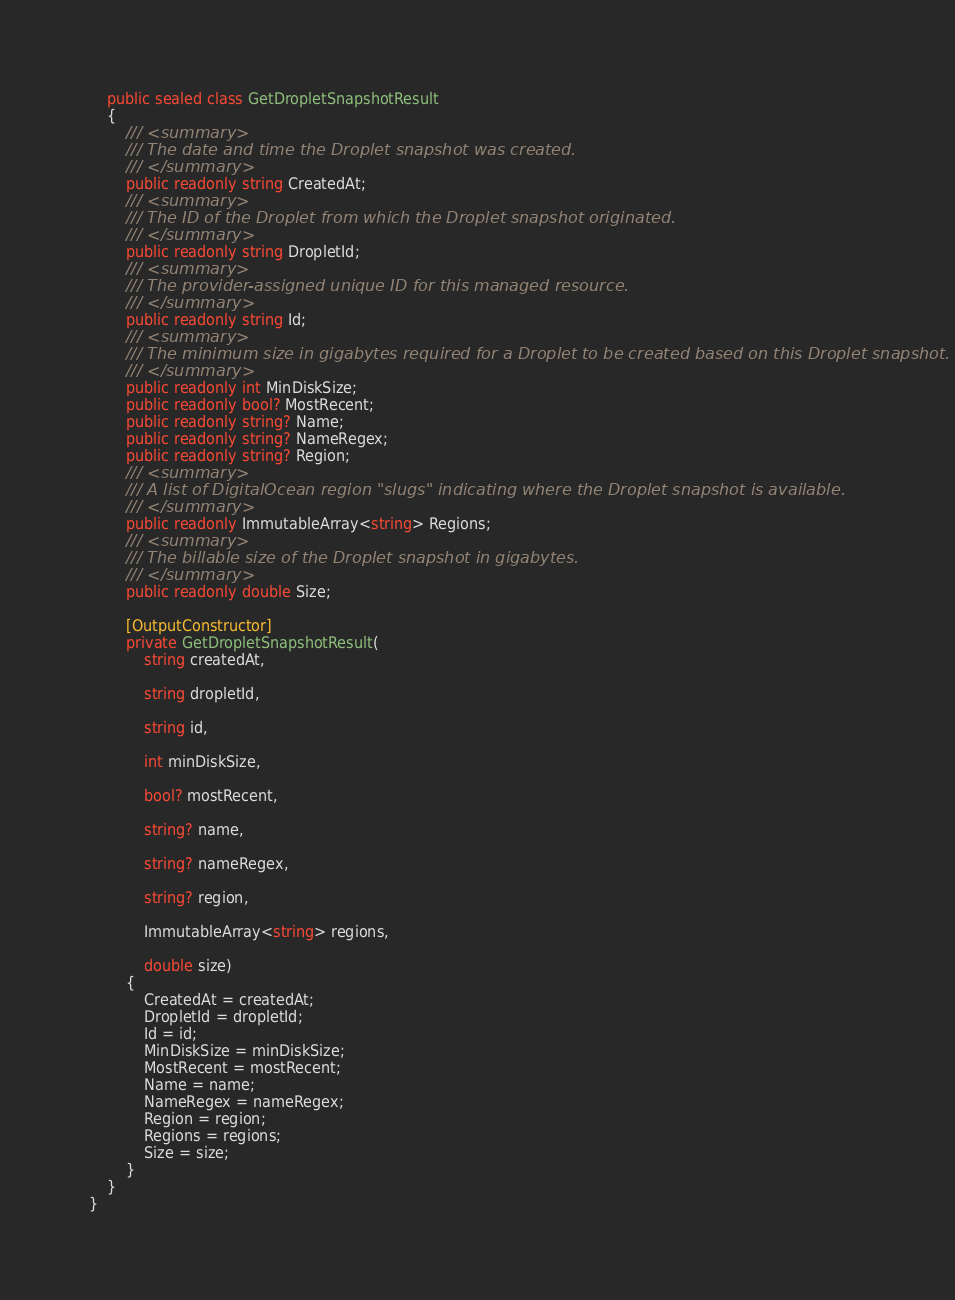Convert code to text. <code><loc_0><loc_0><loc_500><loc_500><_C#_>    public sealed class GetDropletSnapshotResult
    {
        /// <summary>
        /// The date and time the Droplet snapshot was created.
        /// </summary>
        public readonly string CreatedAt;
        /// <summary>
        /// The ID of the Droplet from which the Droplet snapshot originated.
        /// </summary>
        public readonly string DropletId;
        /// <summary>
        /// The provider-assigned unique ID for this managed resource.
        /// </summary>
        public readonly string Id;
        /// <summary>
        /// The minimum size in gigabytes required for a Droplet to be created based on this Droplet snapshot.
        /// </summary>
        public readonly int MinDiskSize;
        public readonly bool? MostRecent;
        public readonly string? Name;
        public readonly string? NameRegex;
        public readonly string? Region;
        /// <summary>
        /// A list of DigitalOcean region "slugs" indicating where the Droplet snapshot is available.
        /// </summary>
        public readonly ImmutableArray<string> Regions;
        /// <summary>
        /// The billable size of the Droplet snapshot in gigabytes.
        /// </summary>
        public readonly double Size;

        [OutputConstructor]
        private GetDropletSnapshotResult(
            string createdAt,

            string dropletId,

            string id,

            int minDiskSize,

            bool? mostRecent,

            string? name,

            string? nameRegex,

            string? region,

            ImmutableArray<string> regions,

            double size)
        {
            CreatedAt = createdAt;
            DropletId = dropletId;
            Id = id;
            MinDiskSize = minDiskSize;
            MostRecent = mostRecent;
            Name = name;
            NameRegex = nameRegex;
            Region = region;
            Regions = regions;
            Size = size;
        }
    }
}
</code> 